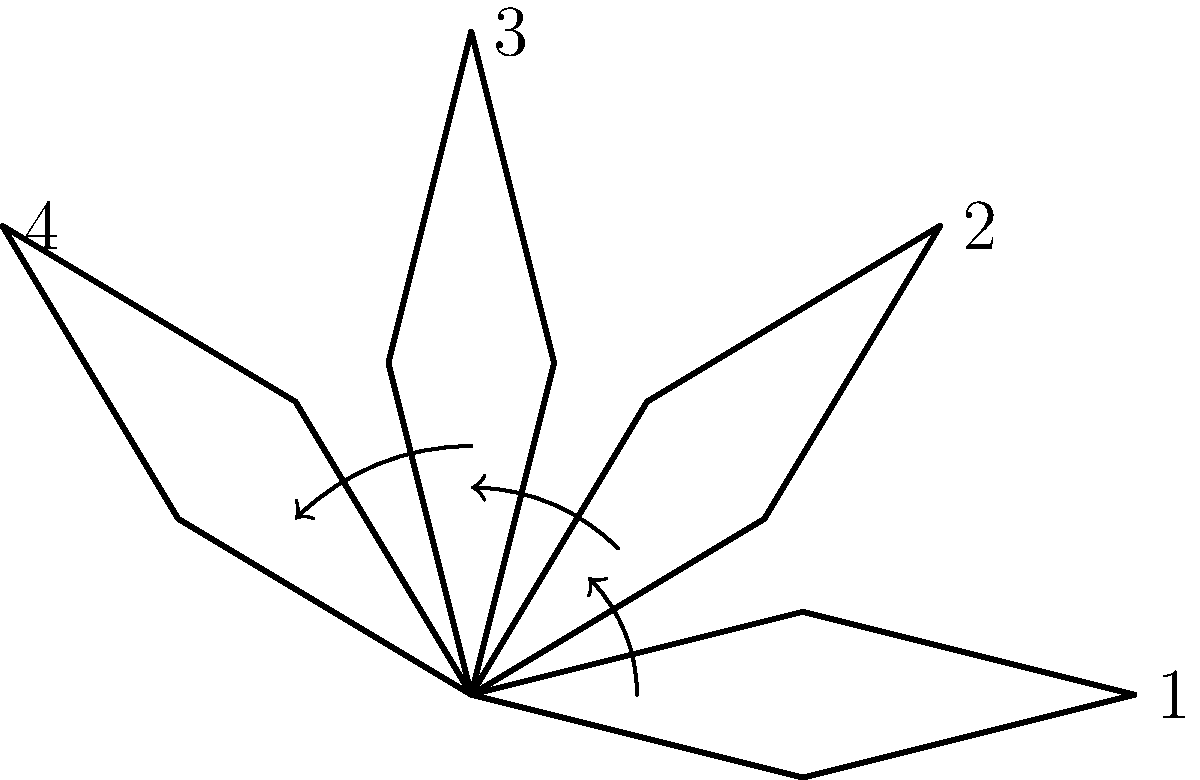As a sales manager at our company, you're presenting a new wing design to potential clients. The diagram shows four rotations of our latest wing design. If the wing is rotated 270° clockwise from its initial position (labeled as 1), which of the shown positions (1, 2, 3, or 4) would it most closely resemble? To solve this problem, we need to follow these steps:

1. Understand the given rotation: 270° clockwise from the initial position.
2. Recognize that a 270° clockwise rotation is equivalent to a 90° counterclockwise rotation.
3. Analyze the diagram:
   - Position 1 is the initial position (0° rotation)
   - Position 2 is rotated 45° counterclockwise from position 1
   - Position 3 is rotated 90° counterclockwise from position 1
   - Position 4 is rotated 135° counterclockwise from position 1

4. Compare the 90° counterclockwise rotation (equivalent to 270° clockwise) to the given positions.

5. Identify that position 3 represents a 90° counterclockwise rotation from the initial position, which is equivalent to the required 270° clockwise rotation.

Therefore, after a 270° clockwise rotation, the wing would most closely resemble position 3 in the diagram.
Answer: 3 